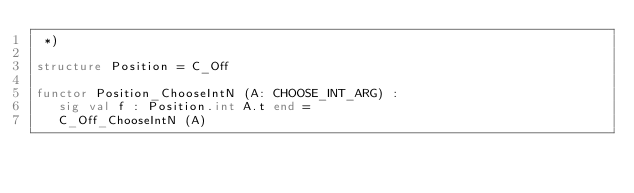Convert code to text. <code><loc_0><loc_0><loc_500><loc_500><_SML_> *)

structure Position = C_Off

functor Position_ChooseIntN (A: CHOOSE_INT_ARG) :
   sig val f : Position.int A.t end =
   C_Off_ChooseIntN (A)
</code> 